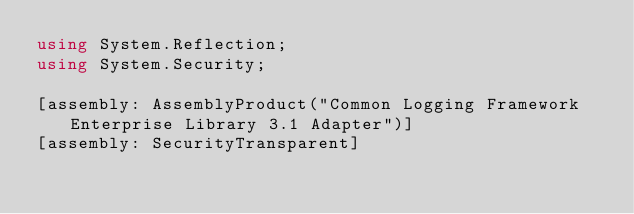Convert code to text. <code><loc_0><loc_0><loc_500><loc_500><_C#_>using System.Reflection;
using System.Security;

[assembly: AssemblyProduct("Common Logging Framework Enterprise Library 3.1 Adapter")]
[assembly: SecurityTransparent]</code> 